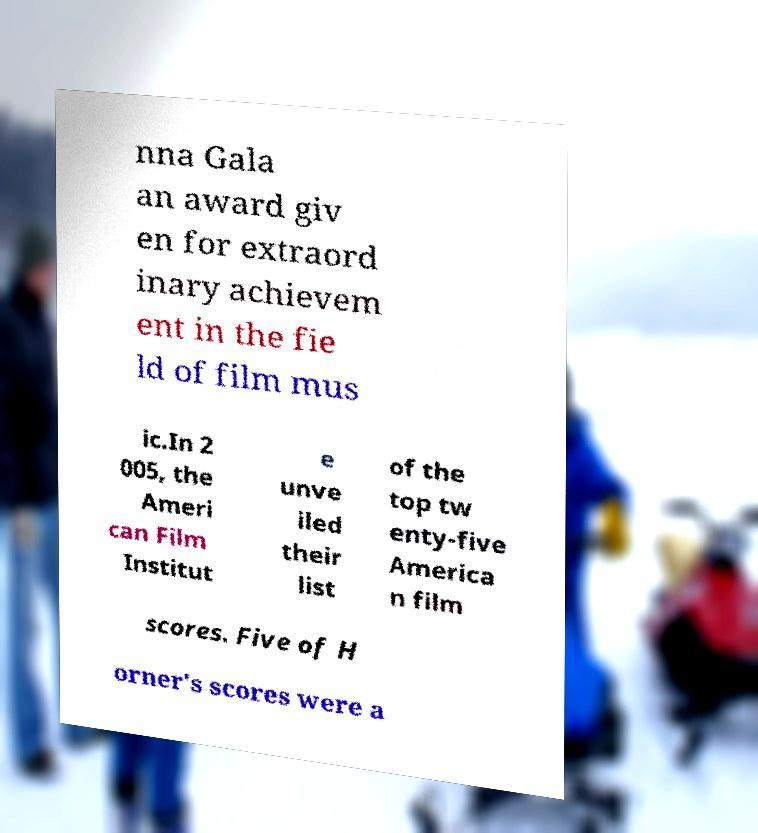There's text embedded in this image that I need extracted. Can you transcribe it verbatim? nna Gala an award giv en for extraord inary achievem ent in the fie ld of film mus ic.In 2 005, the Ameri can Film Institut e unve iled their list of the top tw enty-five America n film scores. Five of H orner's scores were a 